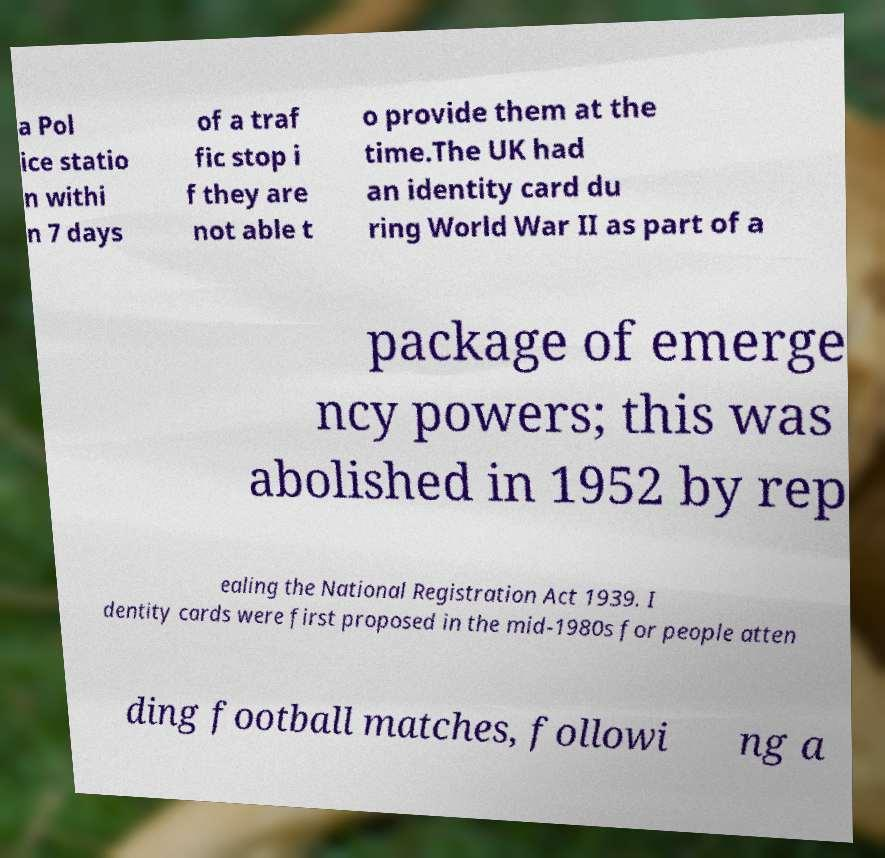For documentation purposes, I need the text within this image transcribed. Could you provide that? a Pol ice statio n withi n 7 days of a traf fic stop i f they are not able t o provide them at the time.The UK had an identity card du ring World War II as part of a package of emerge ncy powers; this was abolished in 1952 by rep ealing the National Registration Act 1939. I dentity cards were first proposed in the mid-1980s for people atten ding football matches, followi ng a 